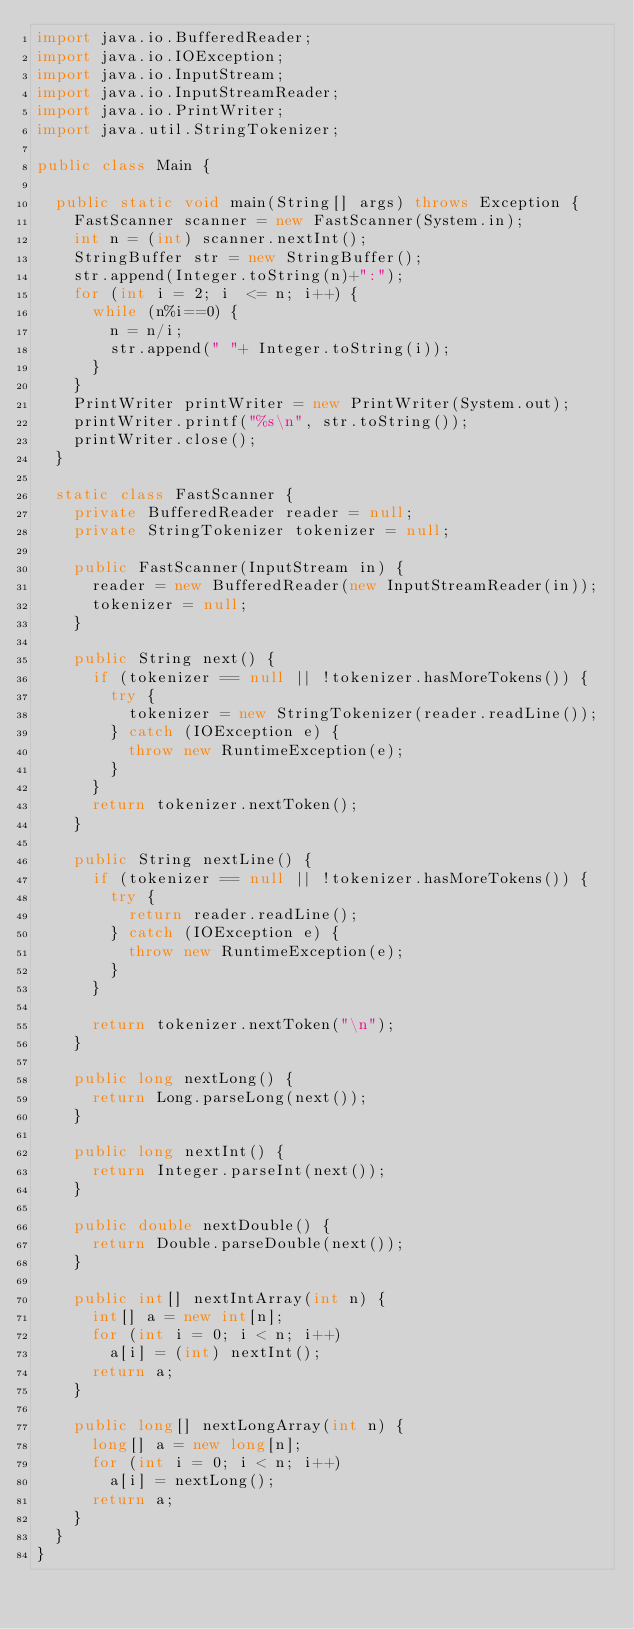Convert code to text. <code><loc_0><loc_0><loc_500><loc_500><_Java_>import java.io.BufferedReader;
import java.io.IOException;
import java.io.InputStream;
import java.io.InputStreamReader;
import java.io.PrintWriter;
import java.util.StringTokenizer;

public class Main {

	public static void main(String[] args) throws Exception {
		FastScanner scanner = new FastScanner(System.in);
		int n = (int) scanner.nextInt();
		StringBuffer str = new StringBuffer();
		str.append(Integer.toString(n)+":");
		for (int i = 2; i  <= n; i++) {
			while (n%i==0) {
				n = n/i;
				str.append(" "+ Integer.toString(i));
			}
		}
		PrintWriter printWriter = new PrintWriter(System.out);
		printWriter.printf("%s\n", str.toString());
		printWriter.close();
	}

	static class FastScanner {
		private BufferedReader reader = null;
		private StringTokenizer tokenizer = null;

		public FastScanner(InputStream in) {
			reader = new BufferedReader(new InputStreamReader(in));
			tokenizer = null;
		}

		public String next() {
			if (tokenizer == null || !tokenizer.hasMoreTokens()) {
				try {
					tokenizer = new StringTokenizer(reader.readLine());
				} catch (IOException e) {
					throw new RuntimeException(e);
				}
			}
			return tokenizer.nextToken();
		}

		public String nextLine() {
			if (tokenizer == null || !tokenizer.hasMoreTokens()) {
				try {
					return reader.readLine();
				} catch (IOException e) {
					throw new RuntimeException(e);
				}
			}

			return tokenizer.nextToken("\n");
		}

		public long nextLong() {
			return Long.parseLong(next());
		}

		public long nextInt() {
			return Integer.parseInt(next());
		}

		public double nextDouble() {
			return Double.parseDouble(next());
		}

		public int[] nextIntArray(int n) {
			int[] a = new int[n];
			for (int i = 0; i < n; i++)
				a[i] = (int) nextInt();
			return a;
		}

		public long[] nextLongArray(int n) {
			long[] a = new long[n];
			for (int i = 0; i < n; i++)
				a[i] = nextLong();
			return a;
		}
	}
}</code> 